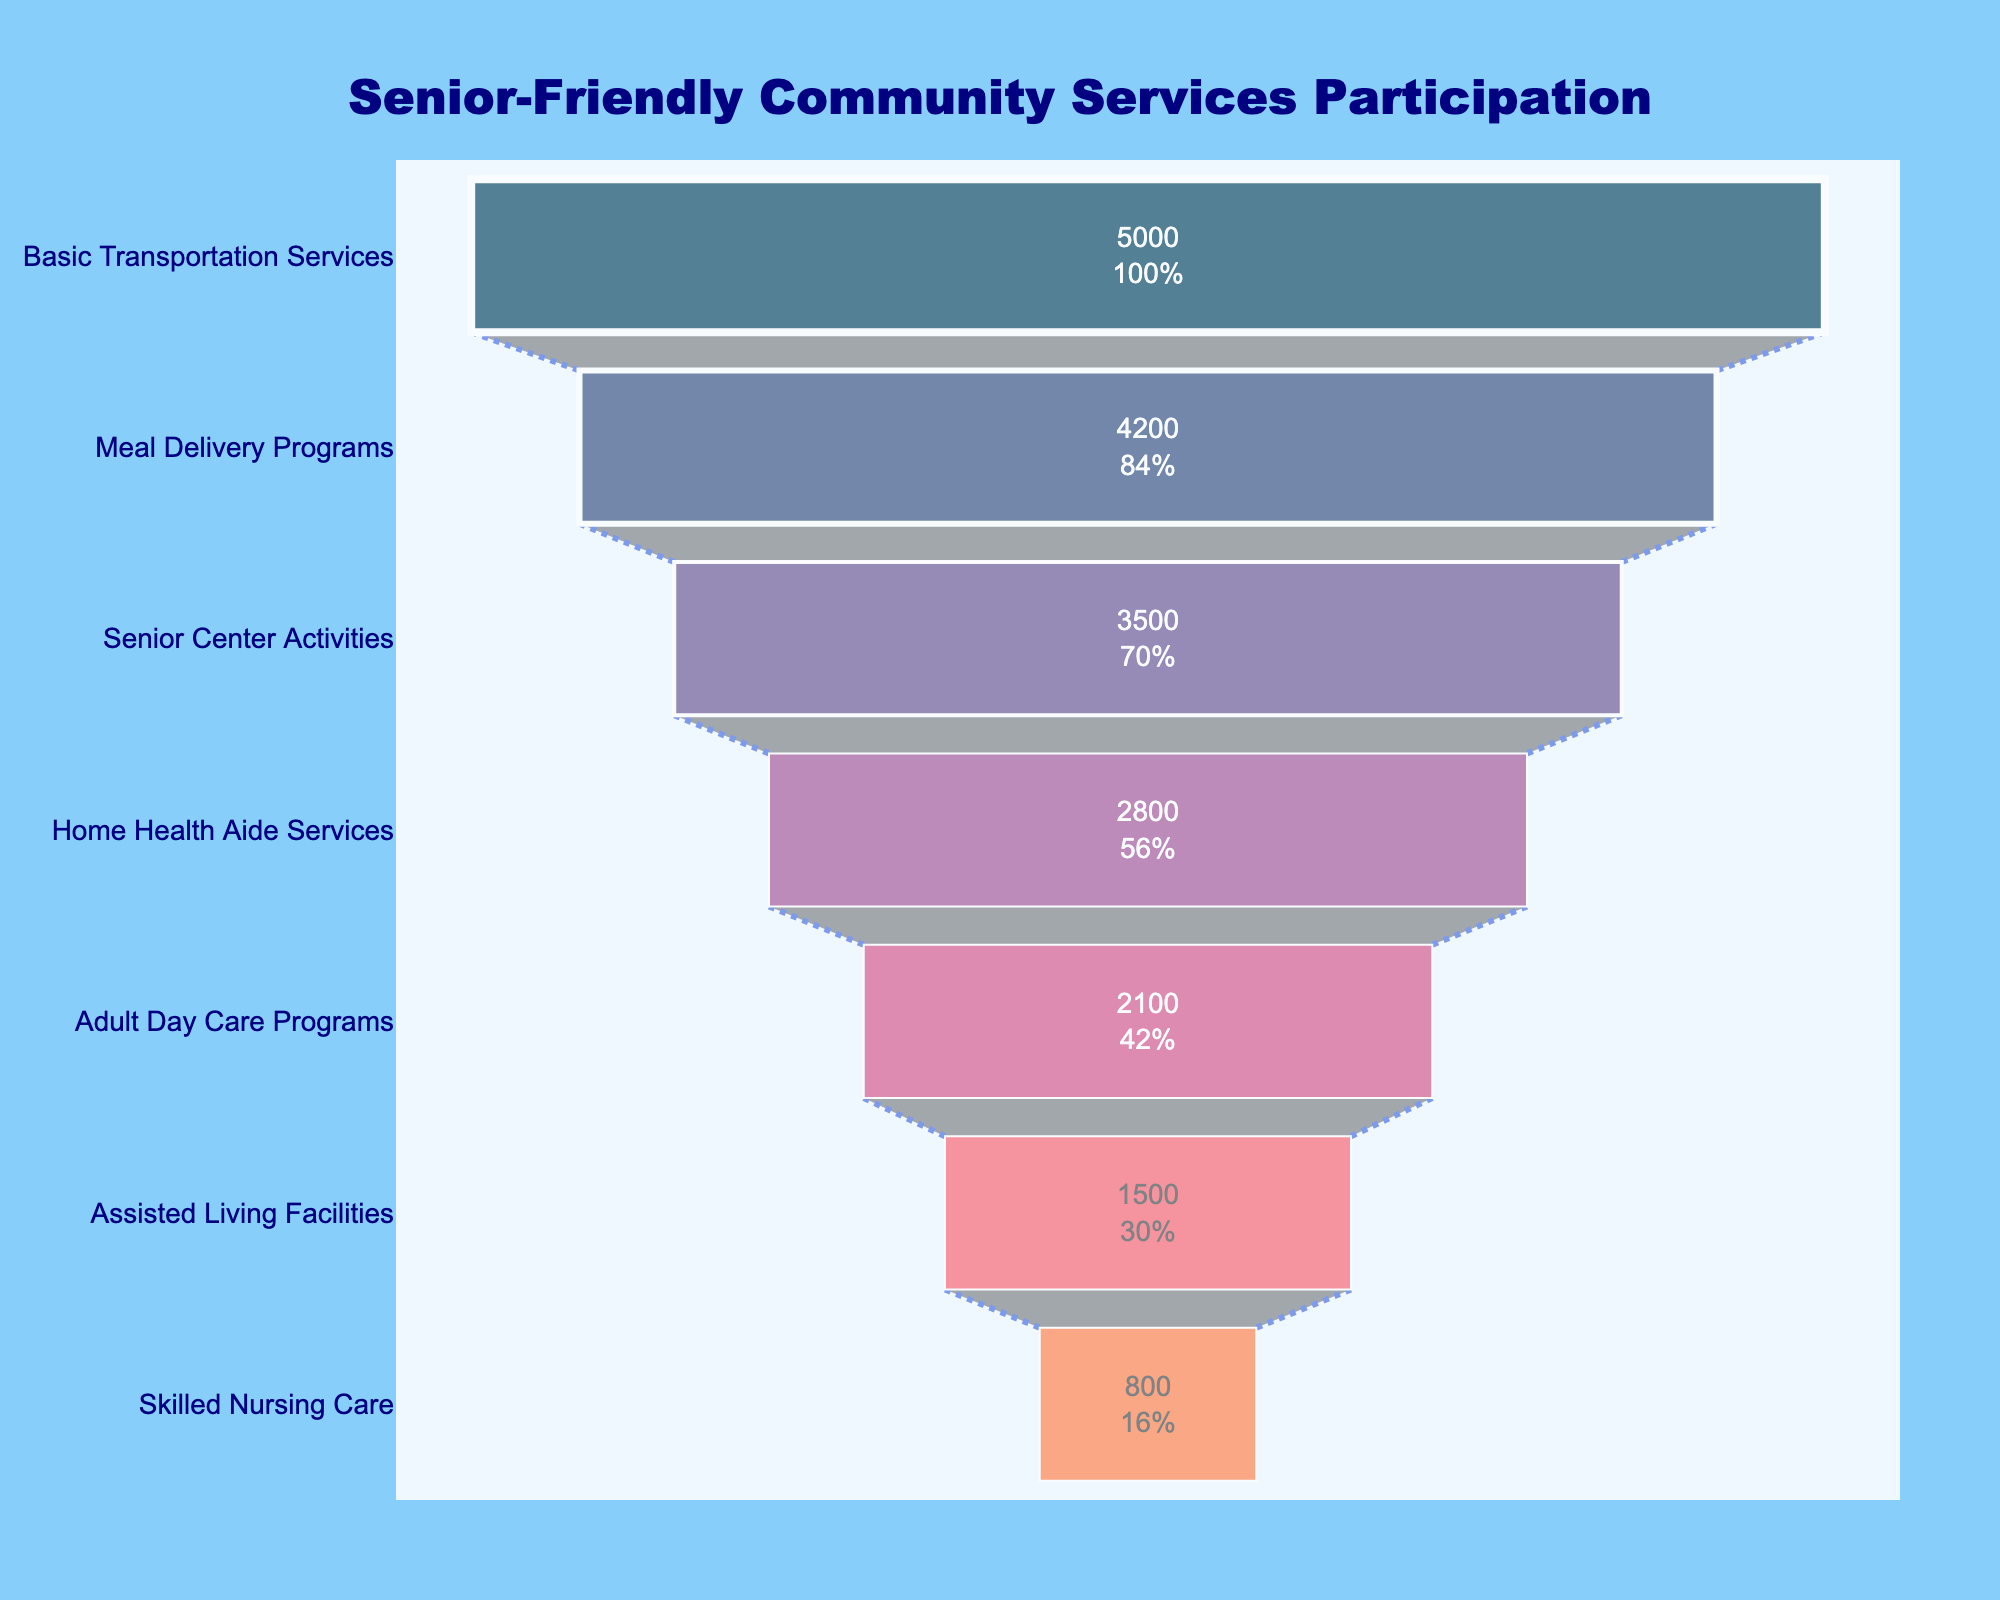What's the title of the chart? The title can be found at the top of the figure. It reads "Senior-Friendly Community Services Participation".
Answer: Senior-Friendly Community Services Participation How many service levels are shown in the funnel chart? We can count the number of unique items listed on the y-axis of the chart. There are seven service levels shown.
Answer: Seven What are the top two services with the highest senior participation? By looking at the top sections of the funnel chart, we see the first two service levels listed, which are 'Basic Transportation Services' and 'Meal Delivery Programs'.
Answer: Basic Transportation Services and Meal Delivery Programs What percentage of seniors participate in Adult Day Care Programs compared to those in Basic Transportation Services? From the chart, note the initial value and the respective participation number. Adult Day Care Programs have 2100 participants, and Basic Transportation Services have 5000 participants. Compute the percentage (2100 / 5000) * 100.
Answer: 42% How many fewer seniors participate in Skilled Nursing Care compared to Meal Delivery Programs? To find the difference, subtract the number of participants in Skilled Nursing Care (800) from those in Meal Delivery Programs (4200).
Answer: 3400 Which service has the least number of seniors participating? By looking at the bottom-most section of the funnel chart, 'Skilled Nursing Care' is the service with the least participation.
Answer: Skilled Nursing Care What is the total number of seniors participating in all services? Sum all the numbers listed for each service level: 5000 + 4200 + 3500 + 2800 + 2100 + 1500 + 800 = 19900.
Answer: 19900 What is the percentage drop in senior participation from Home Health Aide Services to Adult Day Care Programs? Calculate the percentage decrease: ((2800 - 2100) / 2800) * 100.
Answer: 25% Which service level shows the largest drop in senior participation numbers? By subtracting the number of participants between consecutive services listed in descending order, the largest drop is from 'Basic Transportation Services' (5000) to 'Meal Delivery Programs' (4200), which is 800.
Answer: Basic Transportation Services to Meal Delivery Programs What service level comes after Senior Center Activities in terms of senior participation? By referring to the funnel chart, after 'Senior Center Activities' (3500), the next service level is 'Home Health Aide Services' (2800).
Answer: Home Health Aide Services 